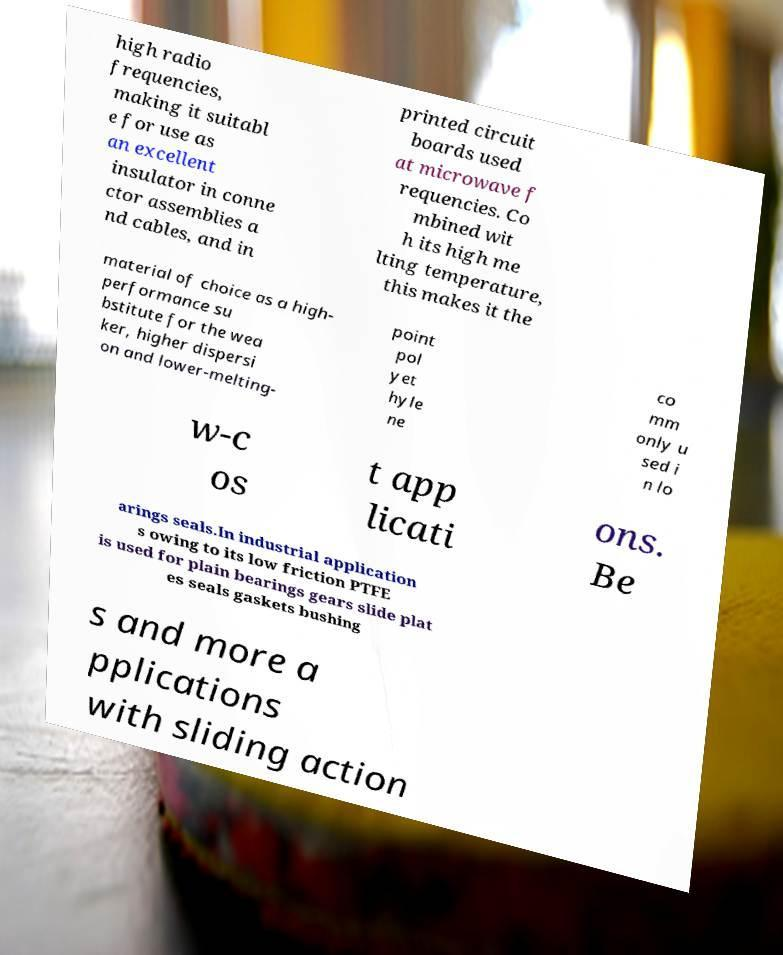Could you extract and type out the text from this image? high radio frequencies, making it suitabl e for use as an excellent insulator in conne ctor assemblies a nd cables, and in printed circuit boards used at microwave f requencies. Co mbined wit h its high me lting temperature, this makes it the material of choice as a high- performance su bstitute for the wea ker, higher dispersi on and lower-melting- point pol yet hyle ne co mm only u sed i n lo w-c os t app licati ons. Be arings seals.In industrial application s owing to its low friction PTFE is used for plain bearings gears slide plat es seals gaskets bushing s and more a pplications with sliding action 